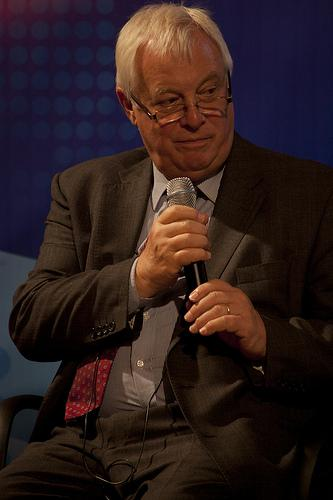Discuss the physical attributes, clothing items and activity of the individual showcased in this image. The man in the image has striking white hair and sports a pair of glasses, complementing his attire which includes a brown suit jacket, a red tie with blue polka dots, and a gold wedding ring on his finger as he speaks into a black, wired microphone. Adopt the persona of a fashion commentator and provide your analysis of the man's outfit and activity. This distinguished gent with white hair and glasses is absolutely nailing the sophisticated speaker look, delivering his message through a sleek black microphone while commanding attention with his brown suit and playful polka-dot red tie. Please briefly summarize the appearance and actions of the main figure in the image. A middle-aged man with white hair and glasses is speaking, while holding a black, corded microphone and wearing a brown suit, red tie, and a gold wedding ring. Elaborate on the style and components of the man's outfit while mentioning the actions he is currently performing. The style-conscious man is speaking into a black wired microphone while sporting an ensemble that includes a brown suit, a gleaming gold ring, and a bold red tie decorated with blue polka dots. In as few words as possible, describe the man in the image and his activity. White-haired, glasses-wearing man speaks into black microphone, wears brown suit, red-blue polka dot tie, and gold ring. Depict the focal individual in the photo and describe the details of their clothing and accessories. We see a man donning eyeglasses, a brown suit and a red tie with blue polka dots, speaking into a black corded microphone. He also wears a gold wedding ring, all while his white hair catches the eye. Provide an elegant and sophisticated description of the man participating in the scene and his ensemble. The debonair, white-haired gentleman engages in discourse, a black microphone in his hand. His ensemble features a tasteful brown suit, vibrant red tie festooned with blue polka dots, and a regal gold wedding band. In a casual tone, describe the most noticeable features and activity of the person in the image. This guy with really white hair, glasses, and a big belly is chatting away with a black microphone in his hand, rocking a brown suit and a red tie with blue polka dots. Envision being a reporter providing an on-the-spot visual account of the man and his actions in the image. Onlookers behold a charismatic figure with flowing white hair and eyeglasses, who captivates his audience as he speaks through a black microphone. His attire consists of a brown suit and an eye-catching red tie adorned with blue polka dots. Using a formal tone, detail the attire and key features of the individual in the image and their current activity. The distinguished gentleman engaged in conversation, features noticeable gray hair, eyeglasses, and a double chin. His attire consists of a well-fitted brown suit, a red and blue polka dot tie, and a gold wedding band. 